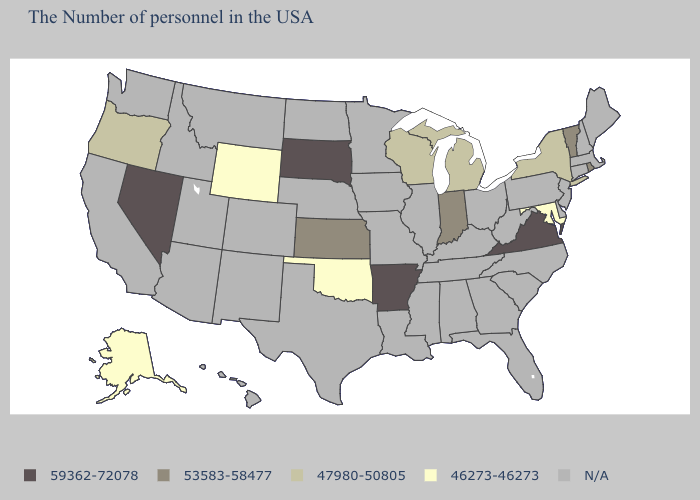Name the states that have a value in the range 53583-58477?
Short answer required. Rhode Island, Vermont, Indiana, Kansas. Does Kansas have the highest value in the MidWest?
Concise answer only. No. What is the value of Connecticut?
Be succinct. N/A. What is the lowest value in the West?
Short answer required. 46273-46273. Does Nevada have the lowest value in the West?
Short answer required. No. What is the value of California?
Answer briefly. N/A. What is the value of Massachusetts?
Answer briefly. N/A. Does the first symbol in the legend represent the smallest category?
Be succinct. No. What is the highest value in the Northeast ?
Quick response, please. 53583-58477. What is the value of Colorado?
Write a very short answer. N/A. Which states have the lowest value in the USA?
Concise answer only. Maryland, Oklahoma, Wyoming, Alaska. What is the lowest value in states that border New York?
Concise answer only. 53583-58477. Among the states that border New York , which have the lowest value?
Be succinct. Vermont. 